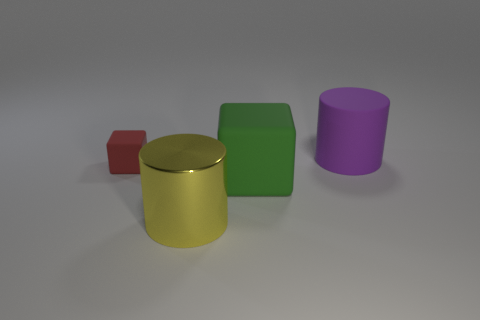Add 3 tiny cyan rubber balls. How many objects exist? 7 Subtract 1 red cubes. How many objects are left? 3 Subtract all big yellow things. Subtract all large rubber objects. How many objects are left? 1 Add 2 cylinders. How many cylinders are left? 4 Add 4 green spheres. How many green spheres exist? 4 